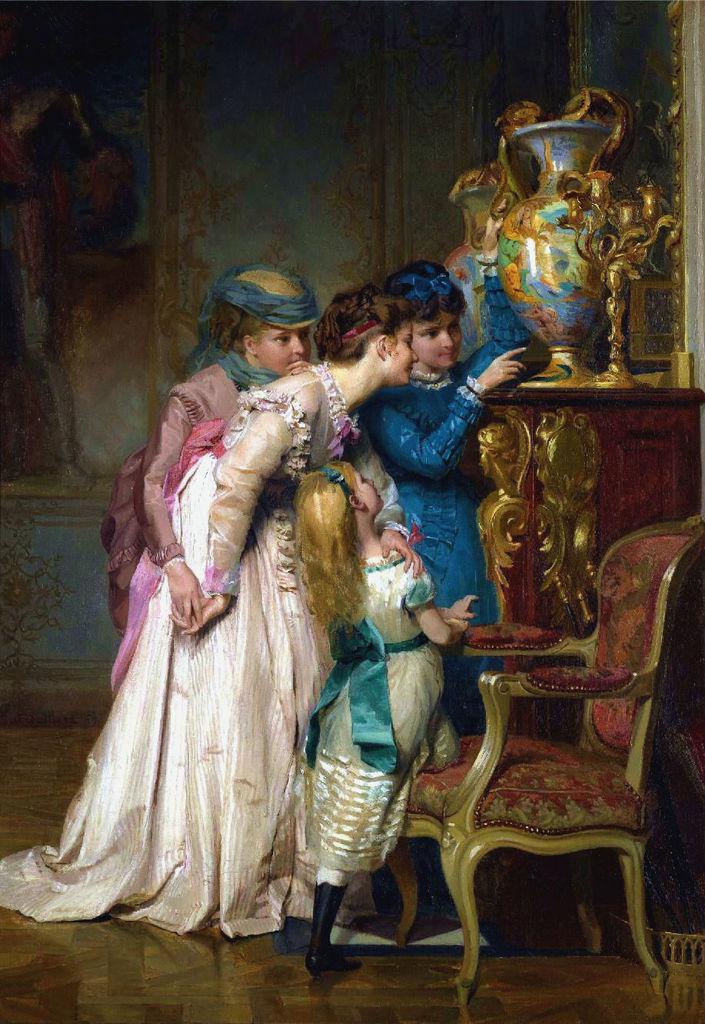Could you give a brief overview of what you see in this image? In the foreground I can see four persons are standing on the floor, chair, table on which a flower vase is there. In the background I can see a wall. This image is taken in a hall. 